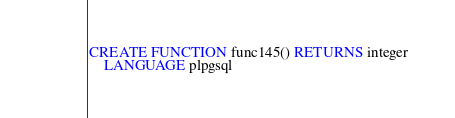Convert code to text. <code><loc_0><loc_0><loc_500><loc_500><_SQL_>CREATE FUNCTION func145() RETURNS integer
    LANGUAGE plpgsql</code> 